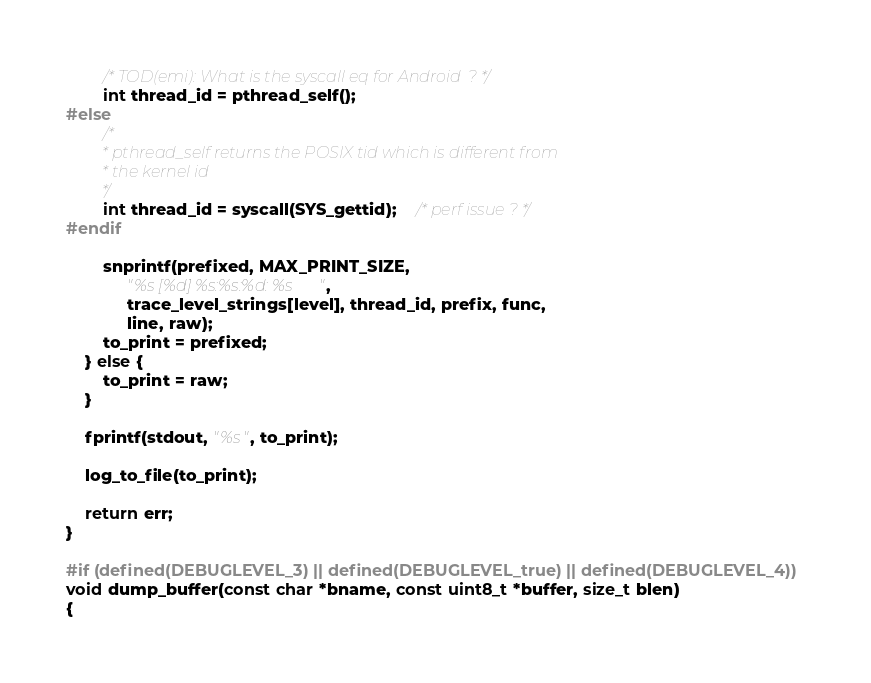<code> <loc_0><loc_0><loc_500><loc_500><_C_>		/* TOD(emi): What is the syscall eq for Android  ? */
		int thread_id = pthread_self();
#else
		/*
		 * pthread_self returns the POSIX tid which is different from
		 * the kernel id
		 */
		int thread_id = syscall(SYS_gettid);	/* perf issue ? */
#endif

		snprintf(prefixed, MAX_PRINT_SIZE,
			 "%s [%d] %s:%s:%d: %s",
			 trace_level_strings[level], thread_id, prefix, func,
			 line, raw);
		to_print = prefixed;
	} else {
		to_print = raw;
	}

	fprintf(stdout, "%s", to_print);

	log_to_file(to_print);

	return err;
}

#if (defined(DEBUGLEVEL_3) || defined(DEBUGLEVEL_true) || defined(DEBUGLEVEL_4))
void dump_buffer(const char *bname, const uint8_t *buffer, size_t blen)
{</code> 